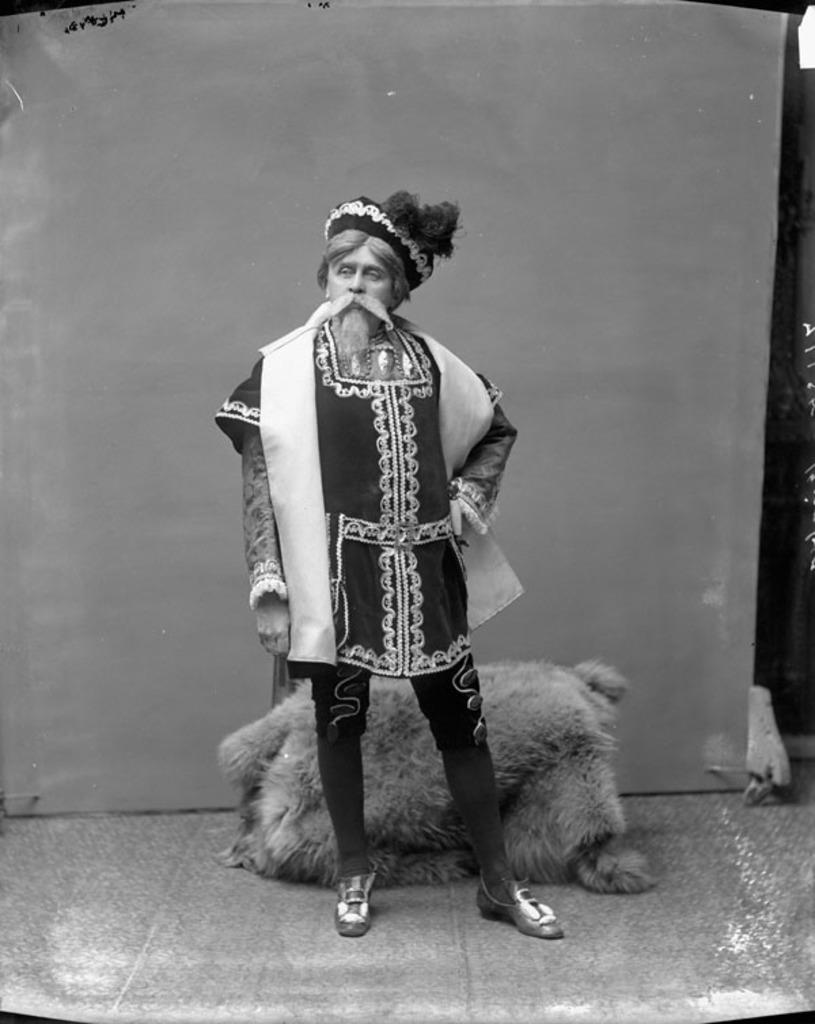In one or two sentences, can you explain what this image depicts? It is a black and white picture. In the center of the image we can see one person standing and he is in a different costume. In the background there is a wall, one animal type object and a few other objects. 